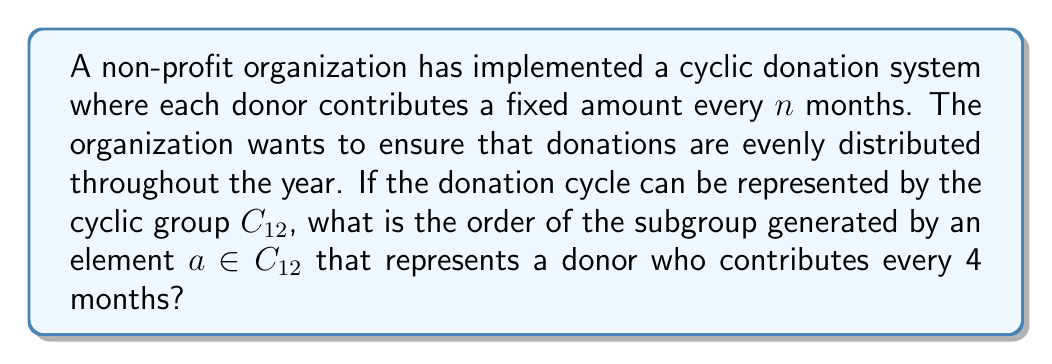Provide a solution to this math problem. To solve this problem, we need to understand the properties of cyclic groups and how they relate to the donation cycle:

1) The group $C_{12}$ represents a 12-month cycle, which is one full year.

2) An element $a \in C_{12}$ that represents a 4-month donation cycle can be expressed as $a = 4$ in the additive notation of $C_{12}$.

3) To find the order of the subgroup generated by $a$, we need to determine the smallest positive integer $k$ such that $ka \equiv 0 \pmod{12}$.

4) This can be expressed as the equation:
   $4k \equiv 0 \pmod{12}$

5) Solving this equation:
   $4k = 12m$, where $m$ is some integer
   $k = 3m$

6) The smallest positive value of $k$ that satisfies this equation is when $m = 1$, giving $k = 3$.

7) This means that after 3 iterations of the 4-month cycle, we return to the starting point in the 12-month cycle:
   $4 + 4 + 4 = 12 \equiv 0 \pmod{12}$

8) Therefore, the order of the subgroup generated by $a$ is 3.

This result indicates that the donation cycle repeats 3 times within a year, which aligns with the 4-month interval between donations.
Answer: The order of the subgroup generated by $a$ is 3. 